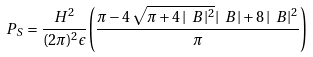<formula> <loc_0><loc_0><loc_500><loc_500>P _ { S } = \frac { H ^ { 2 } } { ( 2 \pi ) ^ { 2 } \epsilon } { \left ( \frac { \pi - 4 \, \sqrt { \pi + 4 \, { | \ B | } ^ { 2 } } | \ B | + 8 \, { | \ B | } ^ { 2 } } { \pi } \right ) }</formula> 